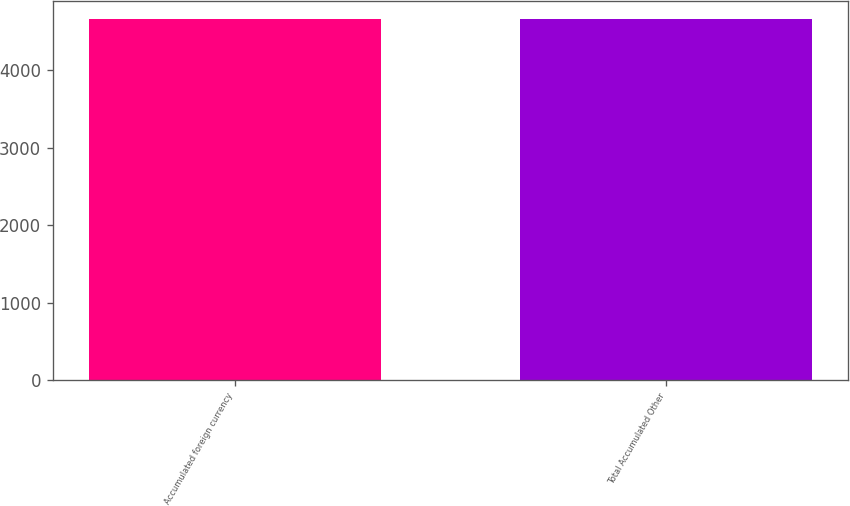<chart> <loc_0><loc_0><loc_500><loc_500><bar_chart><fcel>Accumulated foreign currency<fcel>Total Accumulated Other<nl><fcel>4662<fcel>4662.1<nl></chart> 